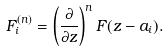Convert formula to latex. <formula><loc_0><loc_0><loc_500><loc_500>F _ { i } ^ { ( n ) } = \left ( \frac { \partial } { \partial z } \right ) ^ { n } F ( z - a _ { i } ) .</formula> 